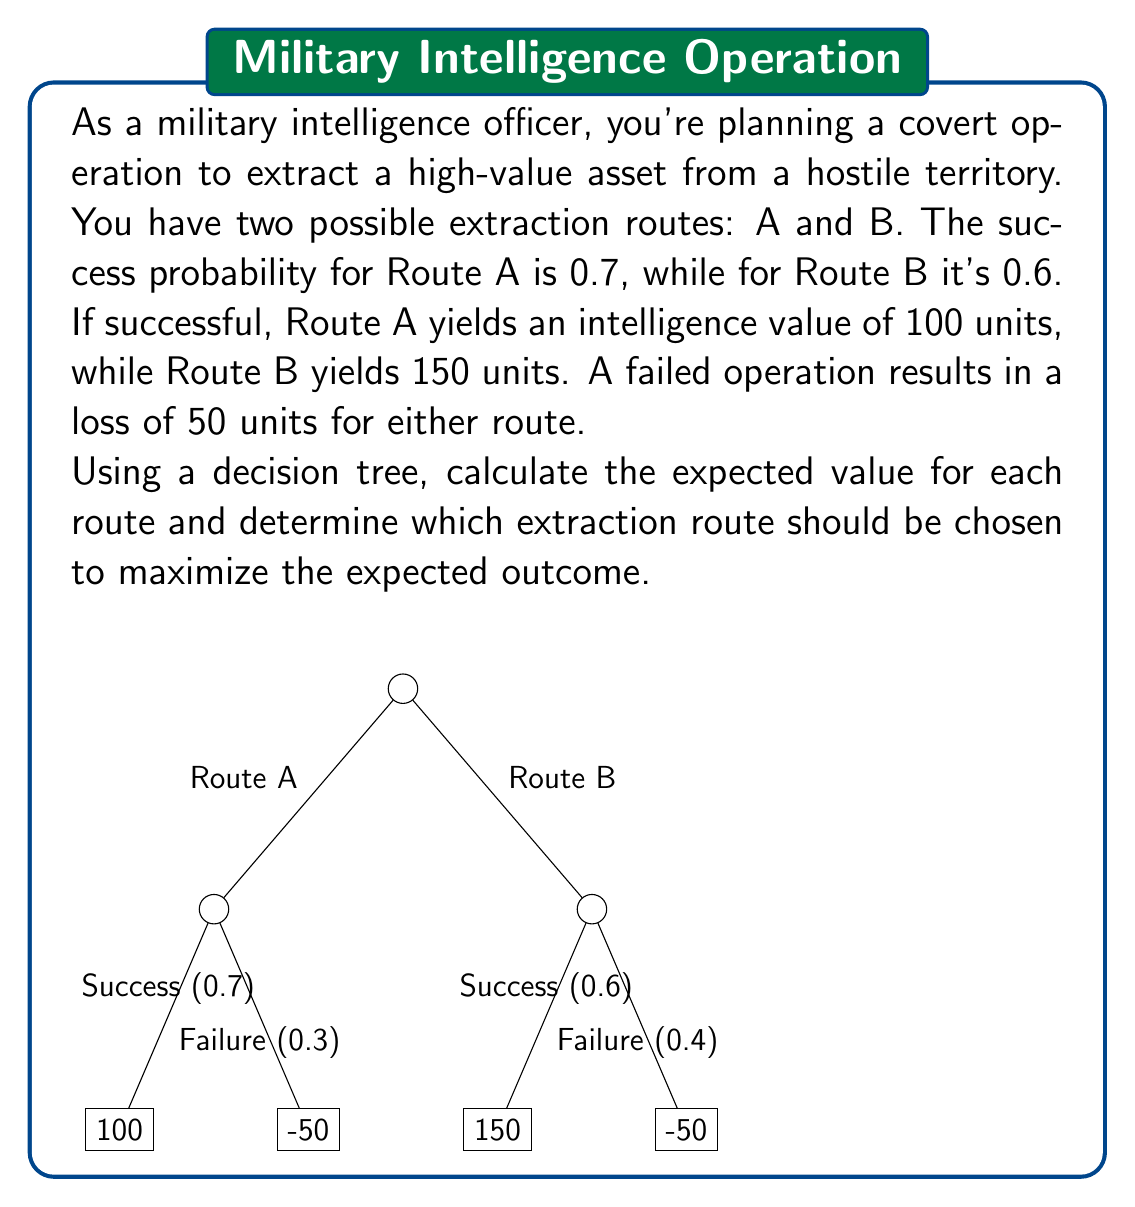What is the answer to this math problem? Let's solve this problem step-by-step using decision tree analysis:

1) For Route A:
   - Success probability: $P(A_s) = 0.7$
   - Failure probability: $P(A_f) = 1 - 0.7 = 0.3$
   - Success value: $V(A_s) = 100$
   - Failure value: $V(A_f) = -50$

   Expected Value of Route A:
   $$E(A) = P(A_s) \cdot V(A_s) + P(A_f) \cdot V(A_f)$$
   $$E(A) = 0.7 \cdot 100 + 0.3 \cdot (-50)$$
   $$E(A) = 70 - 15 = 55$$

2) For Route B:
   - Success probability: $P(B_s) = 0.6$
   - Failure probability: $P(B_f) = 1 - 0.6 = 0.4$
   - Success value: $V(B_s) = 150$
   - Failure value: $V(B_f) = -50$

   Expected Value of Route B:
   $$E(B) = P(B_s) \cdot V(B_s) + P(B_f) \cdot V(B_f)$$
   $$E(B) = 0.6 \cdot 150 + 0.4 \cdot (-50)$$
   $$E(B) = 90 - 20 = 70$$

3) Compare the expected values:
   $E(A) = 55$ units
   $E(B) = 70$ units

   Since $E(B) > E(A)$, Route B has a higher expected value.
Answer: Choose Route B; Expected Value = 70 units 